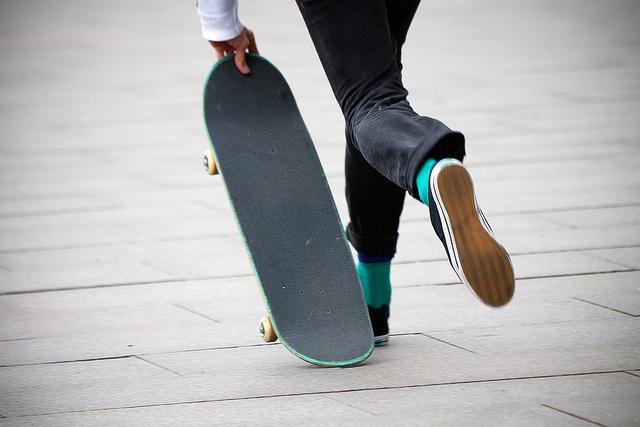How many wheels are shown?
Give a very brief answer. 2. What is the person holding?
Concise answer only. Skateboard. What color socks is the skateboarder wearing?
Quick response, please. Teal. 